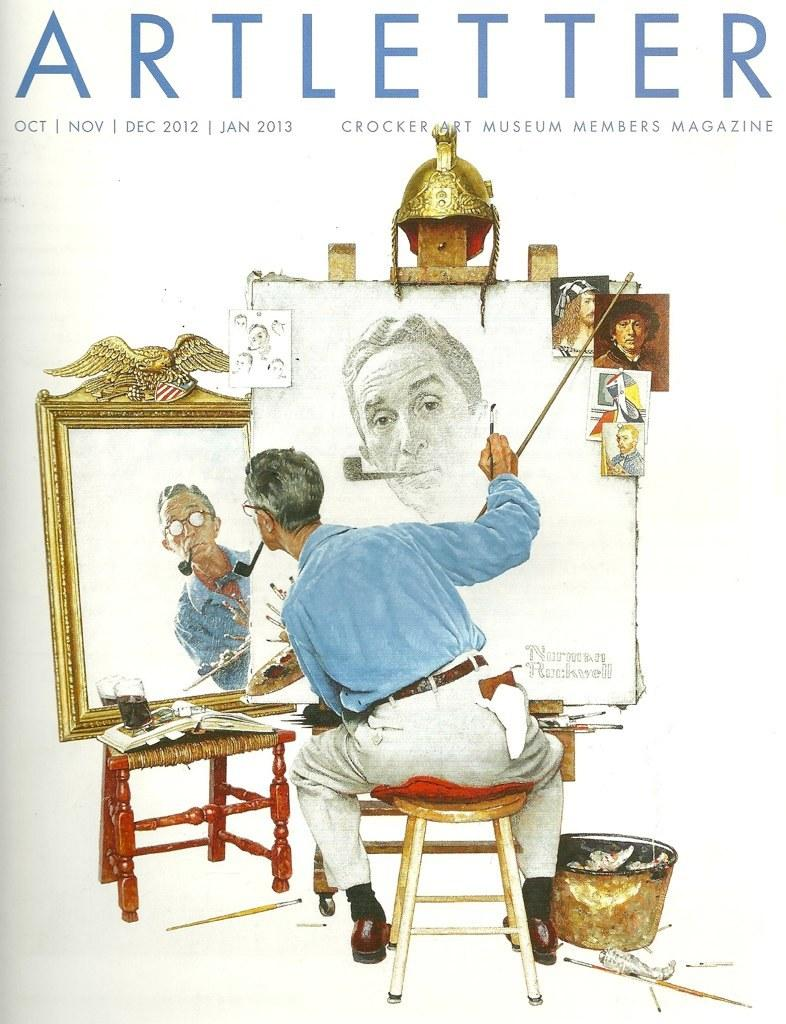What is the main subject in the center of the image? There is a painting in the center of the image. What can be seen in the painting? The painting contains a person. Is there any text present in the image? Yes, there is some text at the top of the image. What type of ray is visible in the painting? There is no ray present in the painting; it contains a person. What meal is being prepared in the image? There is no meal preparation visible in the image; it features a painting with a person and some text. 